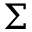<formula> <loc_0><loc_0><loc_500><loc_500>\Sigma</formula> 